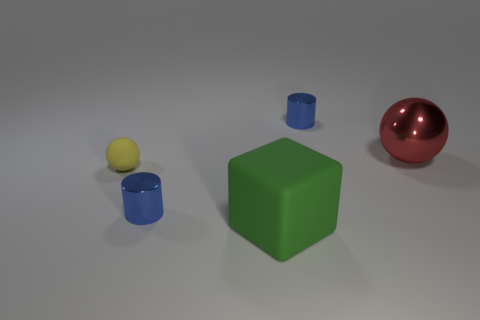Add 2 big red metallic balls. How many objects exist? 7 Subtract all cubes. How many objects are left? 4 Subtract 1 yellow spheres. How many objects are left? 4 Subtract all big cyan matte spheres. Subtract all green objects. How many objects are left? 4 Add 2 rubber objects. How many rubber objects are left? 4 Add 4 metallic objects. How many metallic objects exist? 7 